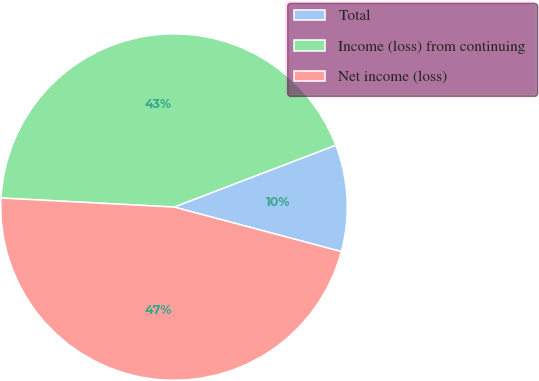<chart> <loc_0><loc_0><loc_500><loc_500><pie_chart><fcel>Total<fcel>Income (loss) from continuing<fcel>Net income (loss)<nl><fcel>9.96%<fcel>43.35%<fcel>46.69%<nl></chart> 